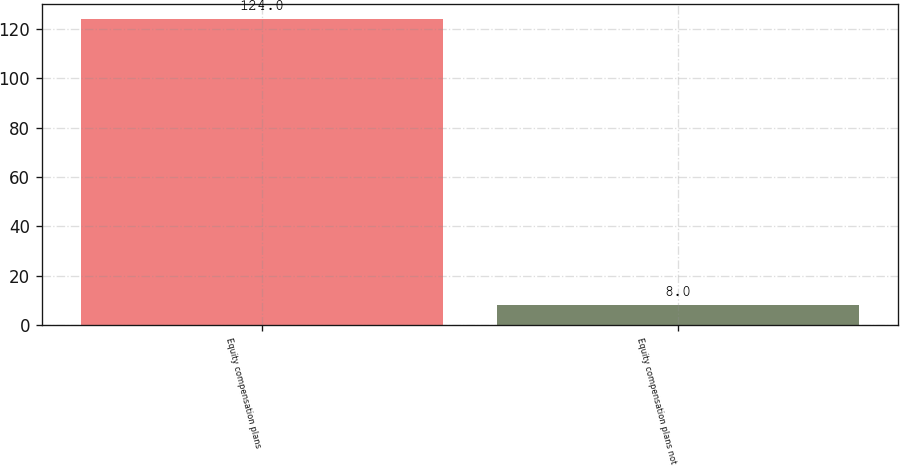Convert chart to OTSL. <chart><loc_0><loc_0><loc_500><loc_500><bar_chart><fcel>Equity compensation plans<fcel>Equity compensation plans not<nl><fcel>124<fcel>8<nl></chart> 